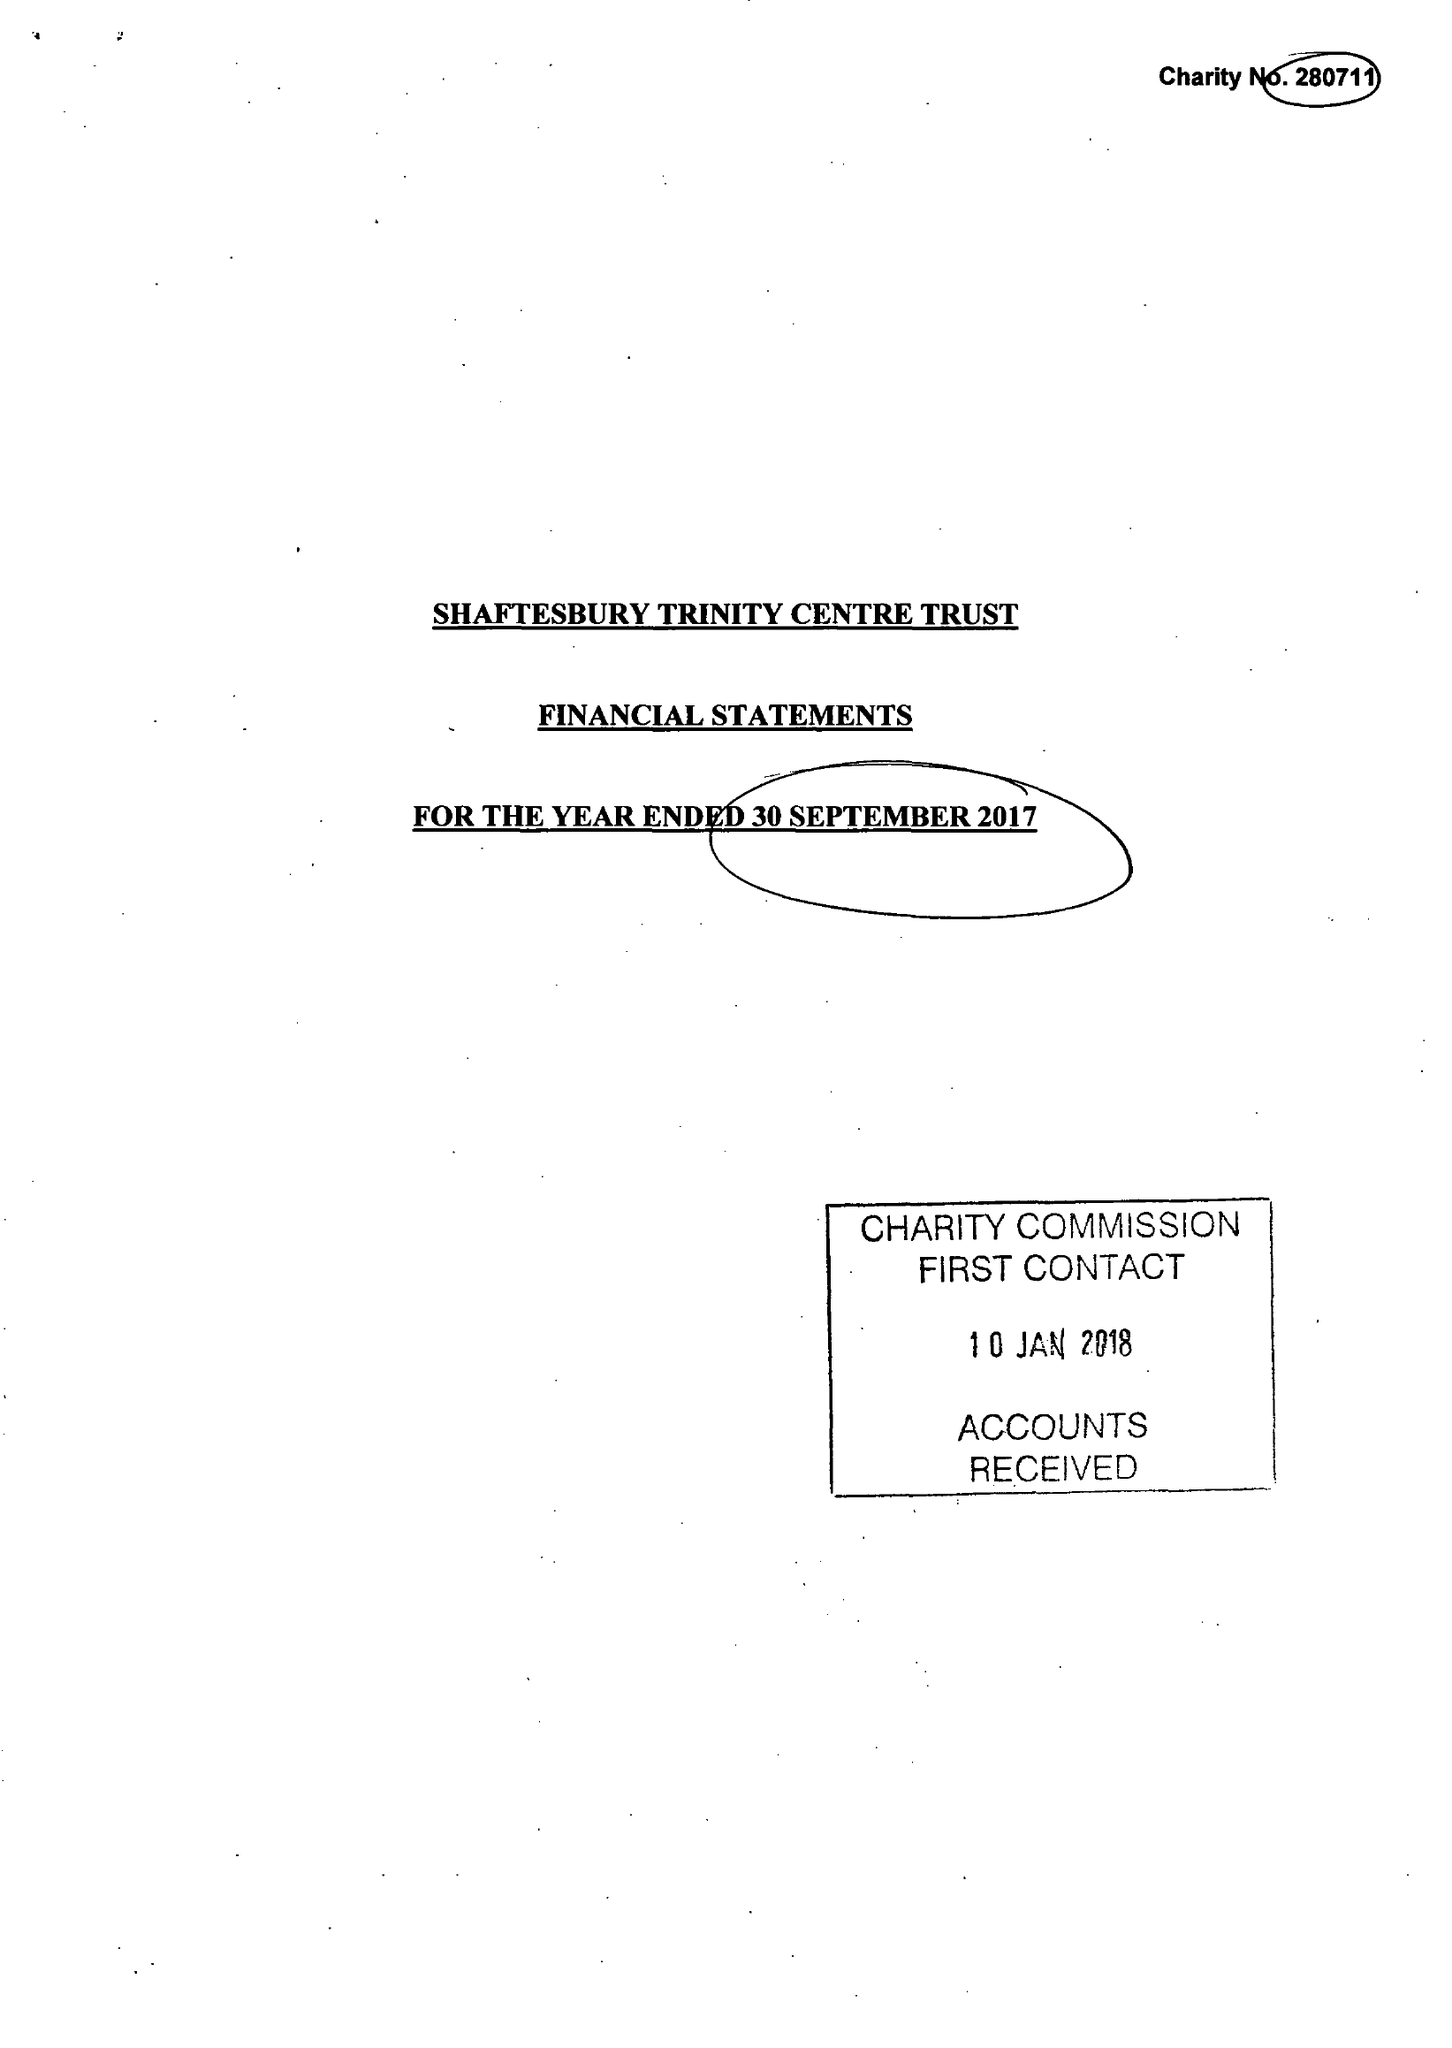What is the value for the address__street_line?
Answer the question using a single word or phrase. None 